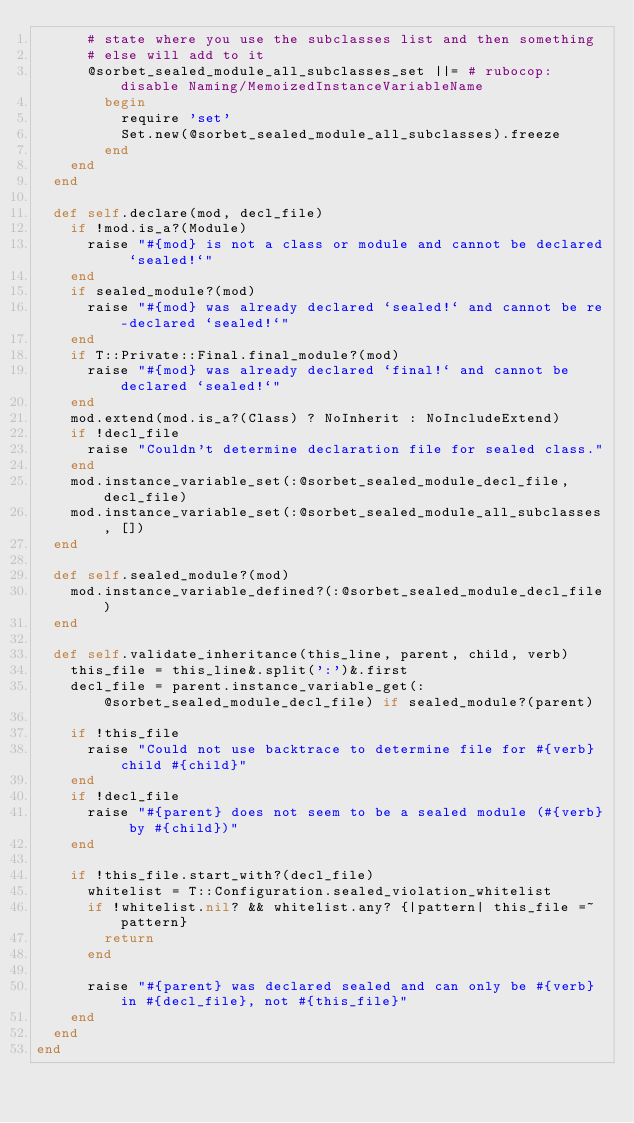Convert code to text. <code><loc_0><loc_0><loc_500><loc_500><_Ruby_>      # state where you use the subclasses list and then something
      # else will add to it
      @sorbet_sealed_module_all_subclasses_set ||= # rubocop:disable Naming/MemoizedInstanceVariableName
        begin
          require 'set'
          Set.new(@sorbet_sealed_module_all_subclasses).freeze
        end
    end
  end

  def self.declare(mod, decl_file)
    if !mod.is_a?(Module)
      raise "#{mod} is not a class or module and cannot be declared `sealed!`"
    end
    if sealed_module?(mod)
      raise "#{mod} was already declared `sealed!` and cannot be re-declared `sealed!`"
    end
    if T::Private::Final.final_module?(mod)
      raise "#{mod} was already declared `final!` and cannot be declared `sealed!`"
    end
    mod.extend(mod.is_a?(Class) ? NoInherit : NoIncludeExtend)
    if !decl_file
      raise "Couldn't determine declaration file for sealed class."
    end
    mod.instance_variable_set(:@sorbet_sealed_module_decl_file, decl_file)
    mod.instance_variable_set(:@sorbet_sealed_module_all_subclasses, [])
  end

  def self.sealed_module?(mod)
    mod.instance_variable_defined?(:@sorbet_sealed_module_decl_file)
  end

  def self.validate_inheritance(this_line, parent, child, verb)
    this_file = this_line&.split(':')&.first
    decl_file = parent.instance_variable_get(:@sorbet_sealed_module_decl_file) if sealed_module?(parent)

    if !this_file
      raise "Could not use backtrace to determine file for #{verb} child #{child}"
    end
    if !decl_file
      raise "#{parent} does not seem to be a sealed module (#{verb} by #{child})"
    end

    if !this_file.start_with?(decl_file)
      whitelist = T::Configuration.sealed_violation_whitelist
      if !whitelist.nil? && whitelist.any? {|pattern| this_file =~ pattern}
        return
      end

      raise "#{parent} was declared sealed and can only be #{verb} in #{decl_file}, not #{this_file}"
    end
  end
end
</code> 